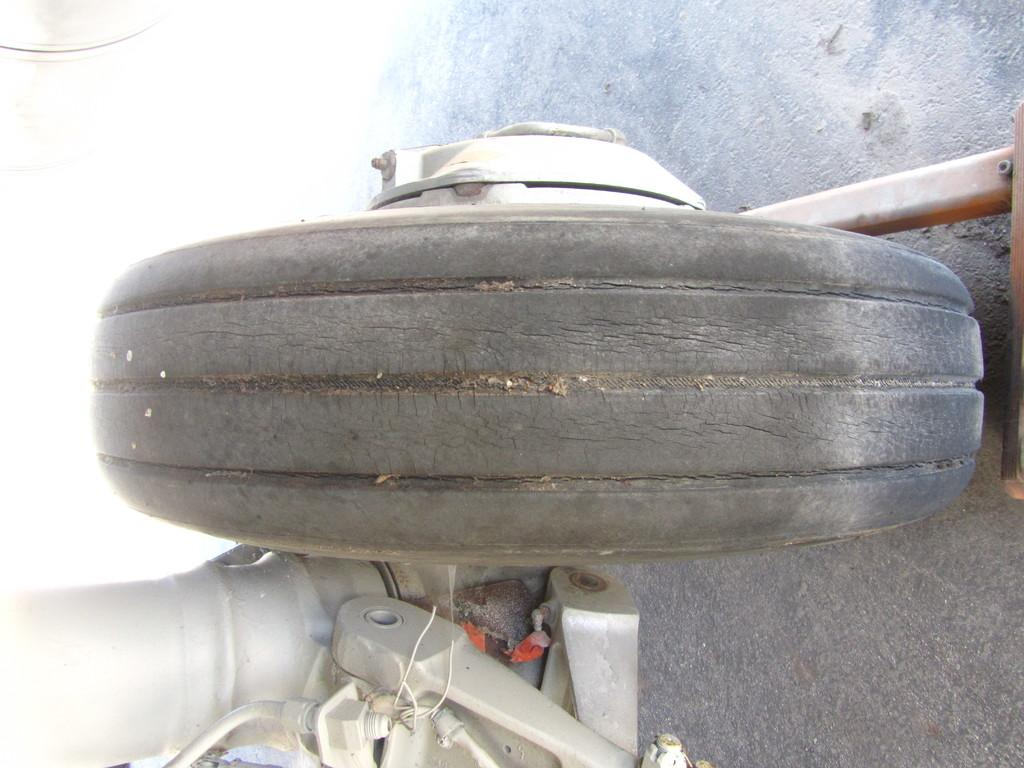What is the main subject of the image? The main subject of the image is an aeroplane Tyre. Where is the aeroplane Tyre located in the image? The aeroplane Tyre is in the center of the image. What type of song are the fairies singing around the aeroplane Tyre in the image? There are no fairies or songs present in the image; it only features an aeroplane Tyre in the center. 